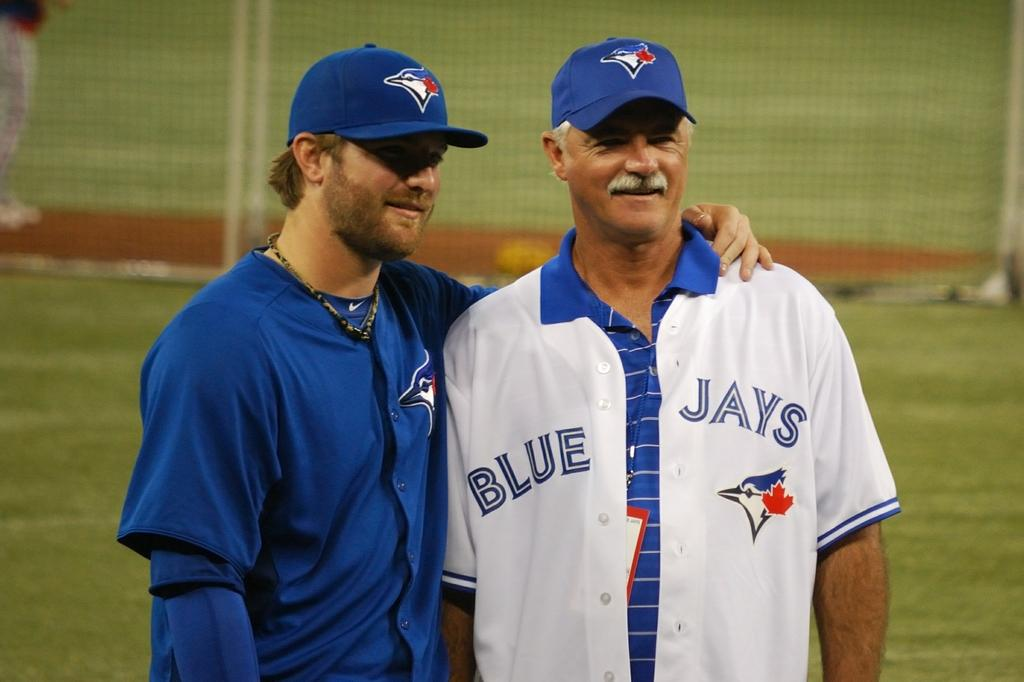<image>
Relay a brief, clear account of the picture shown. Two men wearing Blue Jays uniforms on a baseball field. 